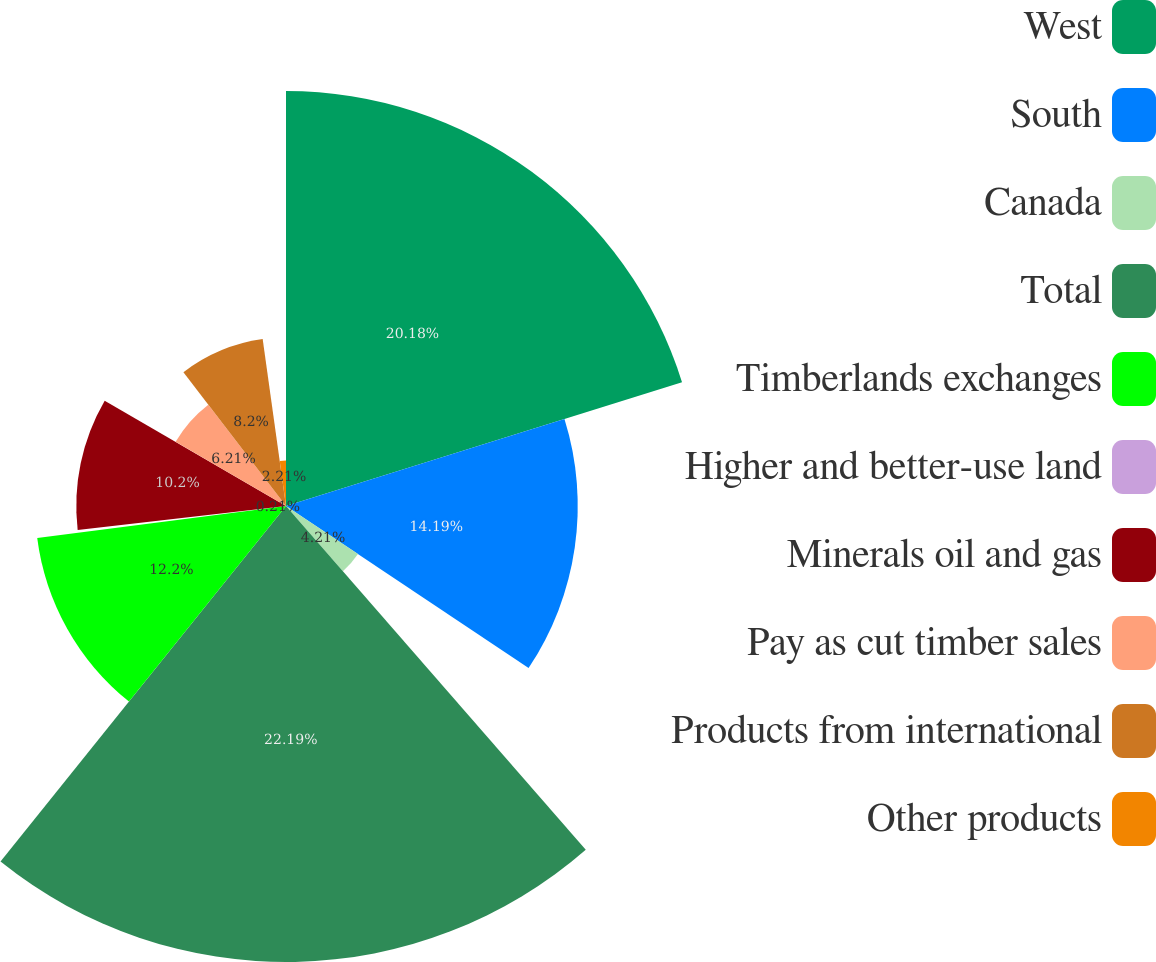<chart> <loc_0><loc_0><loc_500><loc_500><pie_chart><fcel>West<fcel>South<fcel>Canada<fcel>Total<fcel>Timberlands exchanges<fcel>Higher and better-use land<fcel>Minerals oil and gas<fcel>Pay as cut timber sales<fcel>Products from international<fcel>Other products<nl><fcel>20.18%<fcel>14.19%<fcel>4.21%<fcel>22.18%<fcel>12.2%<fcel>0.21%<fcel>10.2%<fcel>6.21%<fcel>8.2%<fcel>2.21%<nl></chart> 